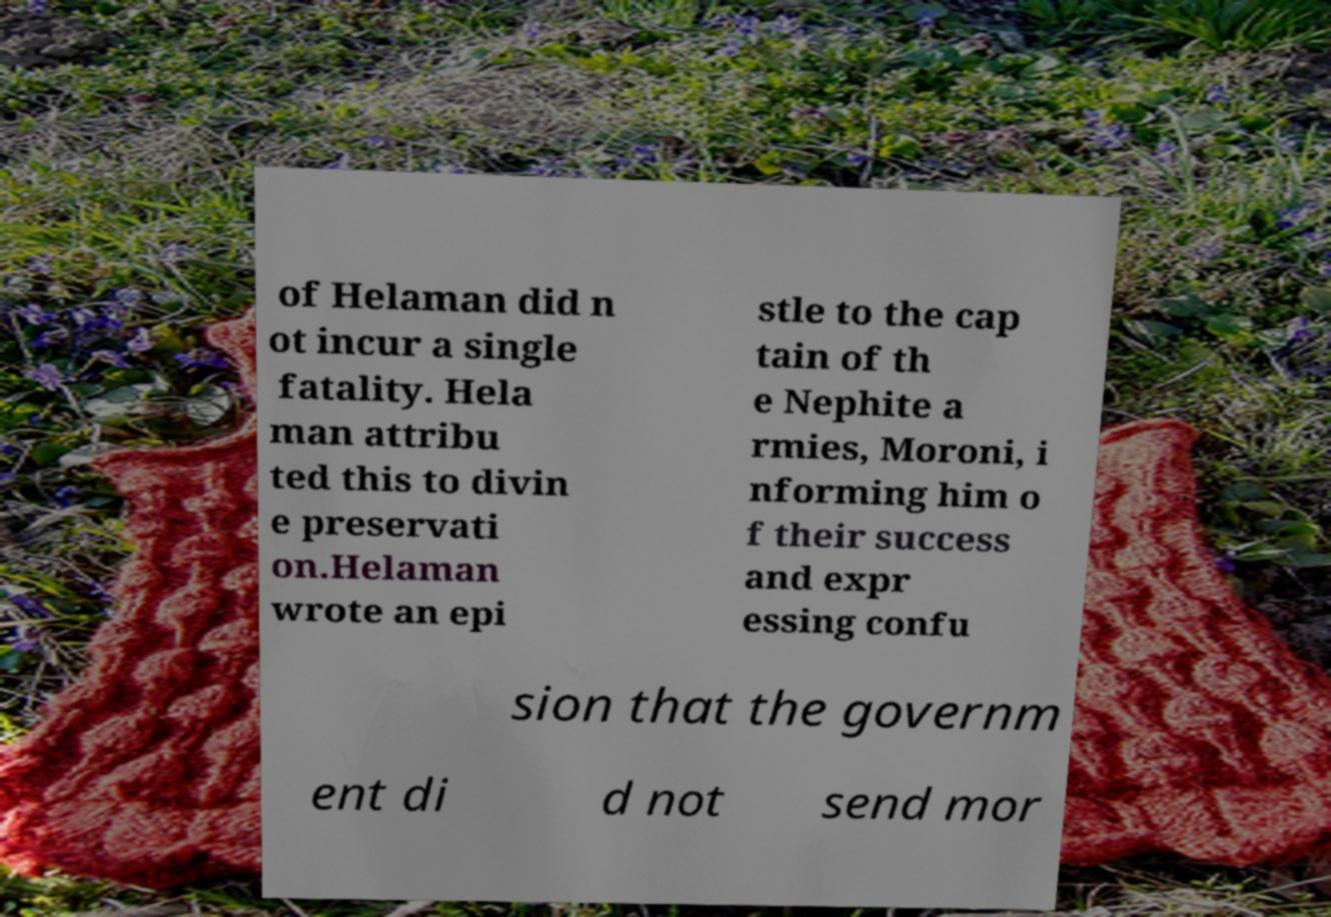What messages or text are displayed in this image? I need them in a readable, typed format. of Helaman did n ot incur a single fatality. Hela man attribu ted this to divin e preservati on.Helaman wrote an epi stle to the cap tain of th e Nephite a rmies, Moroni, i nforming him o f their success and expr essing confu sion that the governm ent di d not send mor 